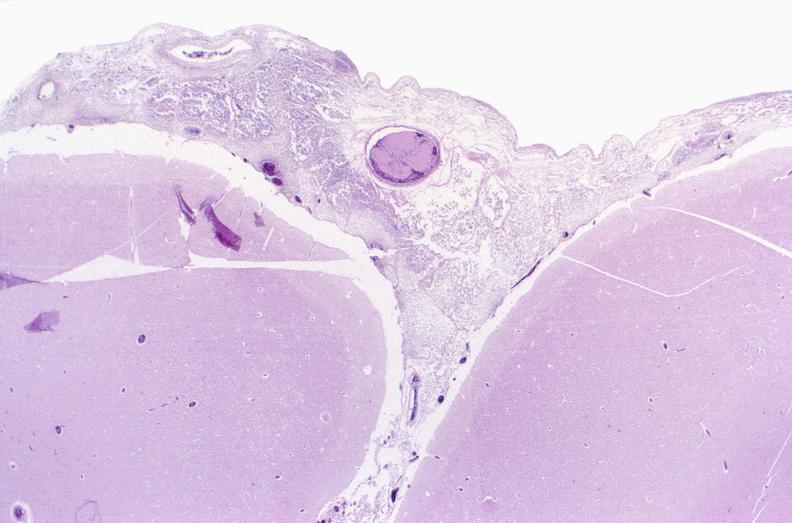what is present?
Answer the question using a single word or phrase. Nervous 